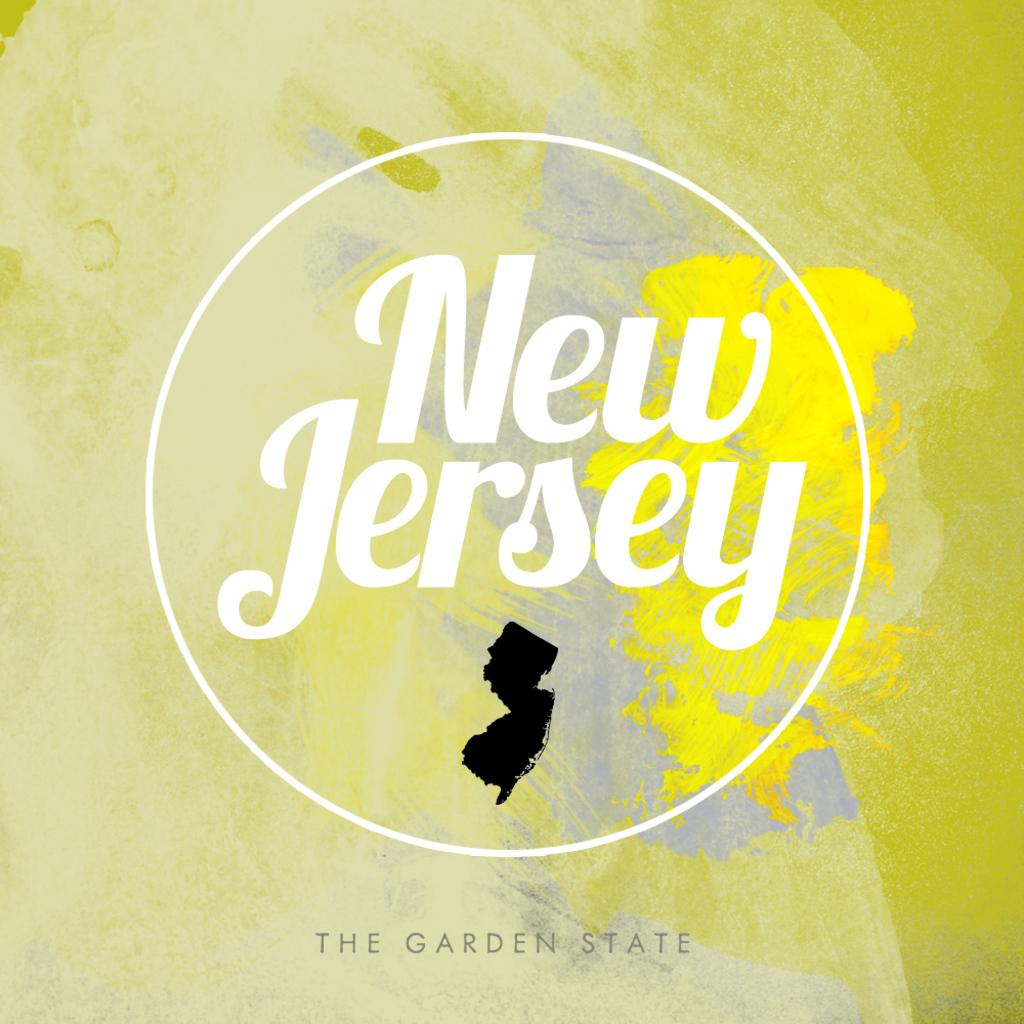What is new jersey's nickname?
Keep it short and to the point. The garden state. What state is mentioned?
Give a very brief answer. New jersey. 